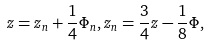<formula> <loc_0><loc_0><loc_500><loc_500>z = z _ { n } + \frac { 1 } { 4 } \Phi _ { n } , z _ { n } = \frac { 3 } { 4 } z - \frac { 1 } { 8 } \Phi ,</formula> 